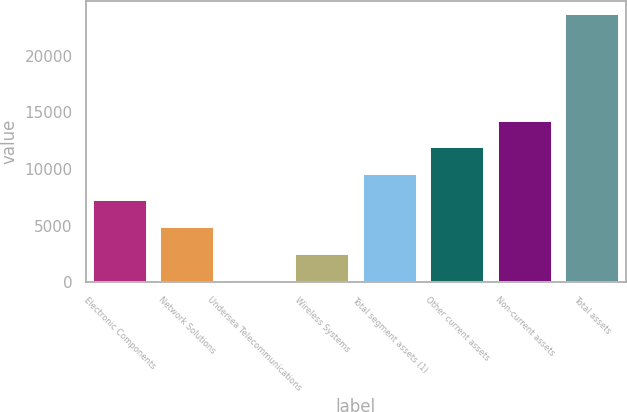<chart> <loc_0><loc_0><loc_500><loc_500><bar_chart><fcel>Electronic Components<fcel>Network Solutions<fcel>Undersea Telecommunications<fcel>Wireless Systems<fcel>Total segment assets (1)<fcel>Other current assets<fcel>Non-current assets<fcel>Total assets<nl><fcel>7214.9<fcel>4861.6<fcel>155<fcel>2508.3<fcel>9568.2<fcel>11921.5<fcel>14274.8<fcel>23688<nl></chart> 